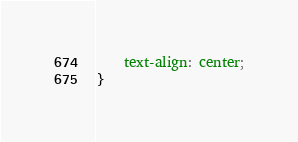Convert code to text. <code><loc_0><loc_0><loc_500><loc_500><_CSS_>    text-align: center;
}</code> 